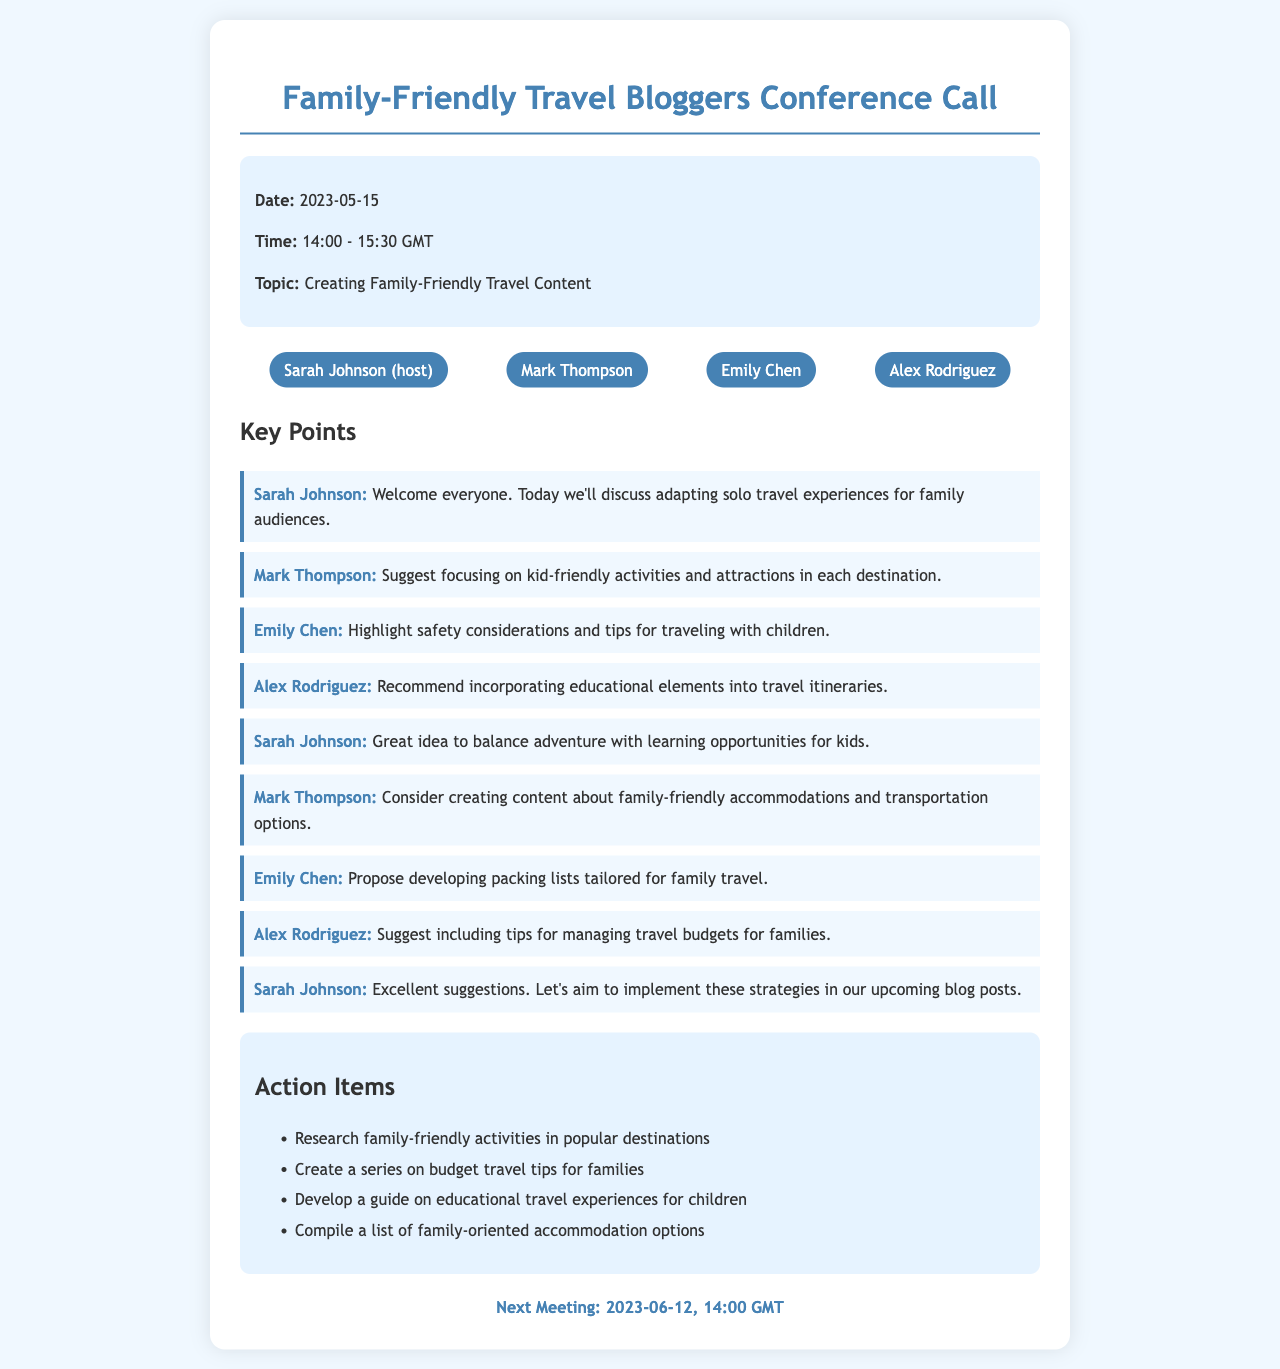What is the date of the conference call? The date of the conference call is stated in the document as May 15, 2023.
Answer: May 15, 2023 Who hosted the conference call? The host of the conference call is identified in the participants section of the document as Sarah Johnson.
Answer: Sarah Johnson What is one key point discussed by Mark Thompson? Mark Thompson made a suggestion during the call regarding focusing on kid-friendly activities in each destination.
Answer: Kid-friendly activities What is one action item listed in the document? One action item mentioned in the action items section is about researching family-friendly activities in popular destinations.
Answer: Research family-friendly activities When is the next meeting scheduled? The next meeting date is listed in the document as June 12, 2023, at 14:00 GMT.
Answer: June 12, 2023 